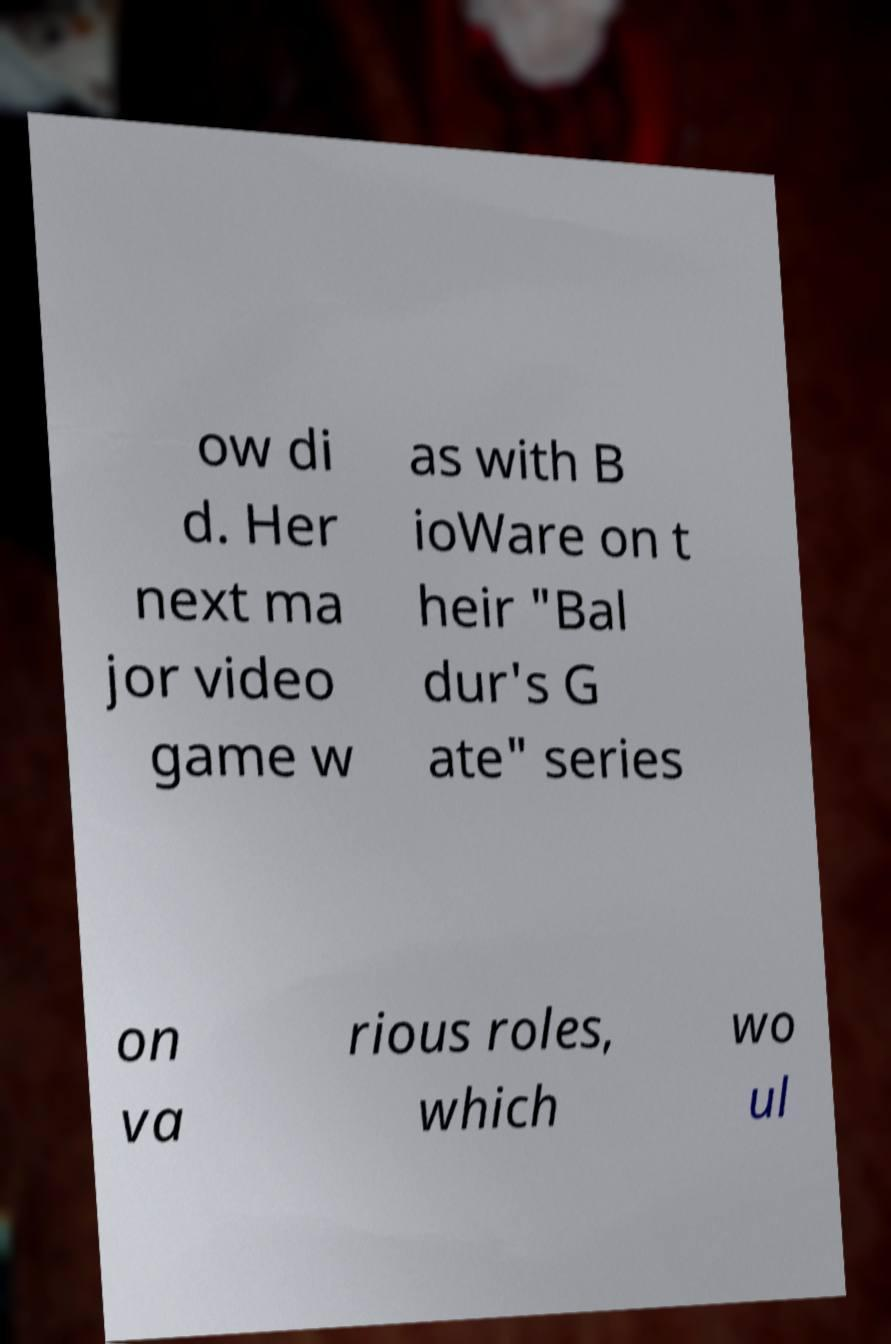For documentation purposes, I need the text within this image transcribed. Could you provide that? ow di d. Her next ma jor video game w as with B ioWare on t heir "Bal dur's G ate" series on va rious roles, which wo ul 